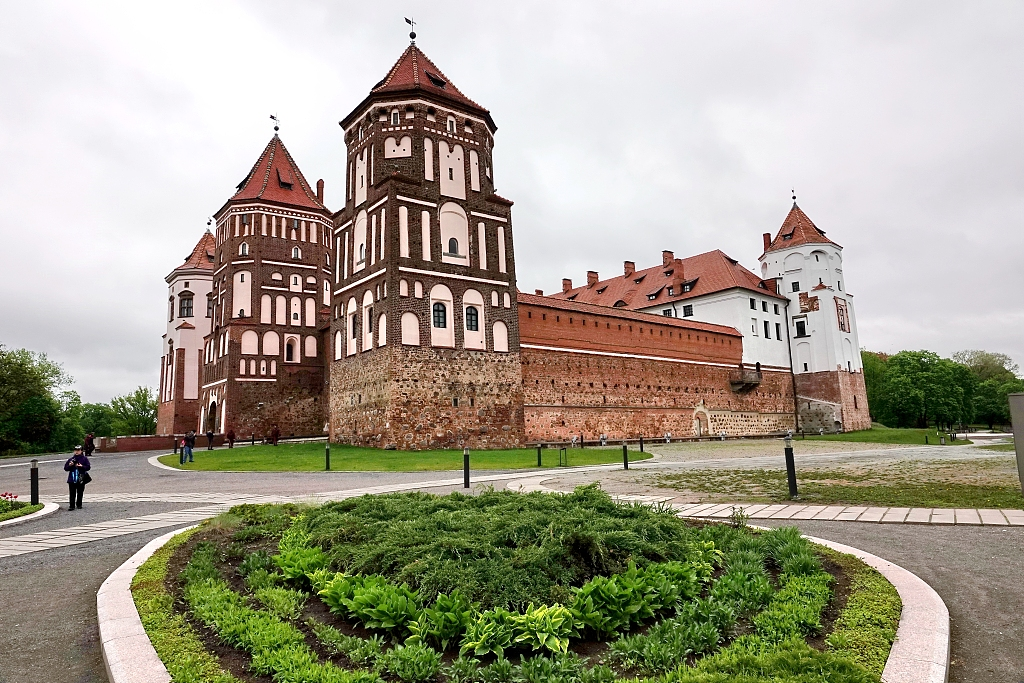Describe what it would have been like to visit this castle during the 16th century. Visiting the Mir Castle in the 16th century would have been an awe-inspiring experience. The castle, a symbol of power and prestige, would have been bustling with activities and life. As a guest, you would likely be greeted by the imposing sight of the massive red brick structure with its towering turrets and fortified walls. Entering through the grand entrance, you would find yourself surrounded by intricate Renaissance art and lavish decor. The castle's halls would be filled with the echo of footsteps and the chatter of nobility discussing politics, trade, and alliances. The smell of fresh bread, roasted meats, and the sound of horses in the stables would add to the vibrant atmosphere. Gardens would be meticulously cared for, reflecting the wealth and sophistication of the castle’s inhabitants. This was a place where history was made, and one could not help but feel the weight of the past while walking through its grand halls and lush gardens. 